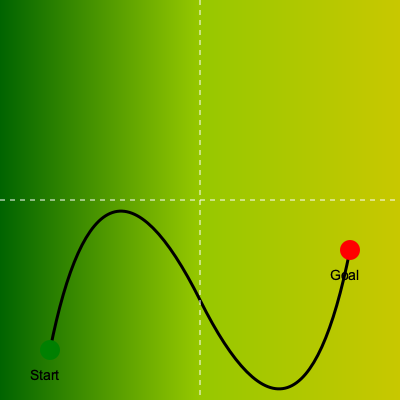Given a topographical map of rugged terrain as shown in the image, where the color gradient represents elevation (darker green being lower elevation and yellow being higher elevation), and considering energy consumption as a function of both distance and elevation change, which path planning algorithm would be most suitable for finding the optimal path from the start (green) to the goal (red) for an autonomous vehicle? Assume the vehicle has limited battery capacity and the objective is to minimize energy consumption while reaching the goal. To determine the most suitable path planning algorithm for this scenario, we need to consider several factors:

1. Terrain complexity: The rugged terrain with varying elevations requires an algorithm that can handle 3D space and continuous cost functions.

2. Energy consumption model: The algorithm needs to account for both distance and elevation changes in its cost function.

3. Completeness and optimality: Given the limited battery capacity, we need an algorithm that can find the optimal solution if one exists.

4. Computational efficiency: The algorithm should be able to handle large search spaces efficiently.

Considering these factors, we can analyze potential algorithms:

1. Dijkstra's algorithm: While it guarantees optimality, it's not efficient for large continuous spaces and doesn't inherently handle 3D terrain.

2. A* search: More efficient than Dijkstra's, but still struggles with continuous 3D spaces and complex cost functions.

3. Rapidly-exploring Random Trees (RRT): Good for high-dimensional spaces, but doesn't guarantee optimality.

4. RRT*: An asymptotically optimal version of RRT, but may require long computation times for optimality.

5. Potential Field Methods: Can be efficient but often get stuck in local minima.

6. Sampling-based algorithms (e.g., PRM, PRM*): Can handle complex spaces but may require significant preprocessing.

The most suitable algorithm for this scenario is the RRT* (RRT-star) algorithm with custom cost function. Here's why:

1. RRT* can efficiently handle high-dimensional, continuous spaces like the 3D terrain in our problem.

2. It allows for a custom cost function that can incorporate both distance and elevation changes to model energy consumption accurately.

3. RRT* is asymptotically optimal, meaning it will converge to the optimal solution given enough time, which is crucial for finding the most energy-efficient path.

4. It can quickly find a feasible solution and then improve it over time, which is useful if computational resources are limited.

5. RRT* can easily incorporate constraints like battery capacity by pruning paths that exceed the energy budget.

To implement this:

1. Define the cost function as $c = \alpha d + \beta \Delta h$, where $d$ is distance, $\Delta h$ is elevation change, and $\alpha$ and $\beta$ are weighting factors based on the vehicle's energy consumption characteristics.

2. Use the topographical map to create a 3D representation of the terrain.

3. Implement RRT* with the custom cost function, starting from the green point and targeting the red point.

4. Add a constraint to prune paths that exceed the total available energy based on the vehicle's battery capacity.

5. Allow the algorithm to run and refine the solution until a satisfactory path is found or computational resources are exhausted.

This approach will provide an energy-efficient path that considers both distance and elevation changes while ensuring the vehicle can reach the goal within its battery limitations.
Answer: RRT* (RRT-star) with custom energy-based cost function 